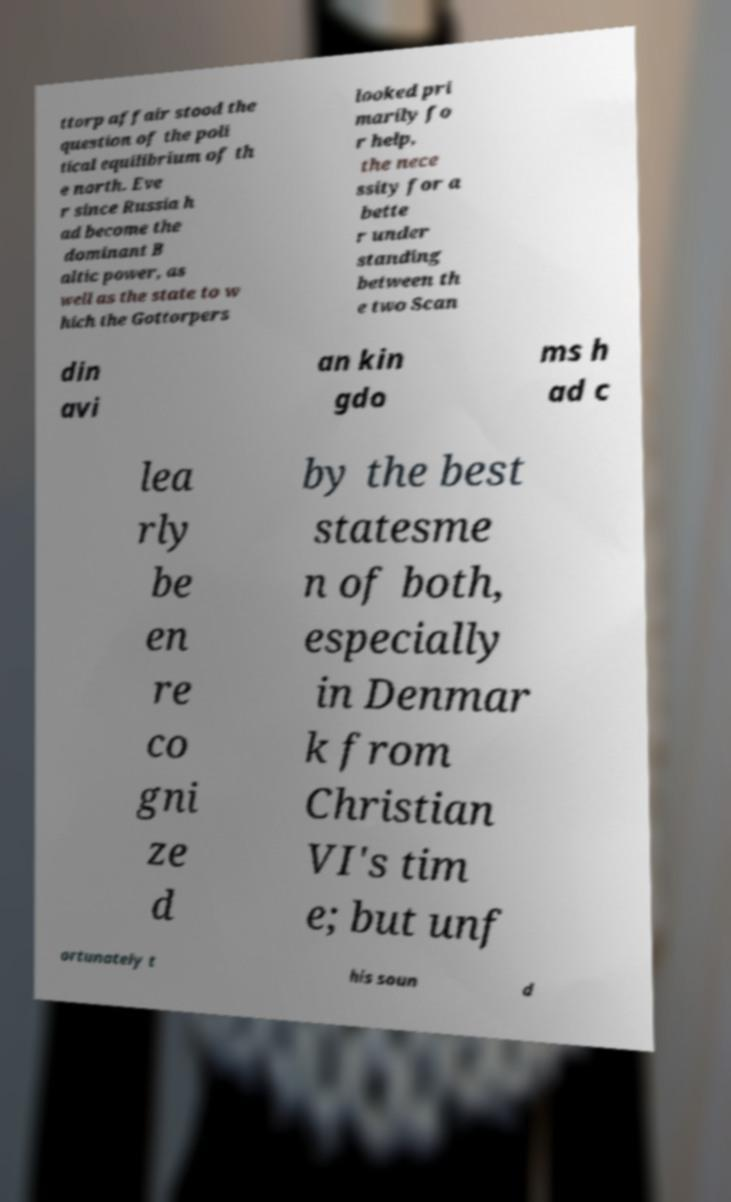What messages or text are displayed in this image? I need them in a readable, typed format. ttorp affair stood the question of the poli tical equilibrium of th e north. Eve r since Russia h ad become the dominant B altic power, as well as the state to w hich the Gottorpers looked pri marily fo r help, the nece ssity for a bette r under standing between th e two Scan din avi an kin gdo ms h ad c lea rly be en re co gni ze d by the best statesme n of both, especially in Denmar k from Christian VI's tim e; but unf ortunately t his soun d 